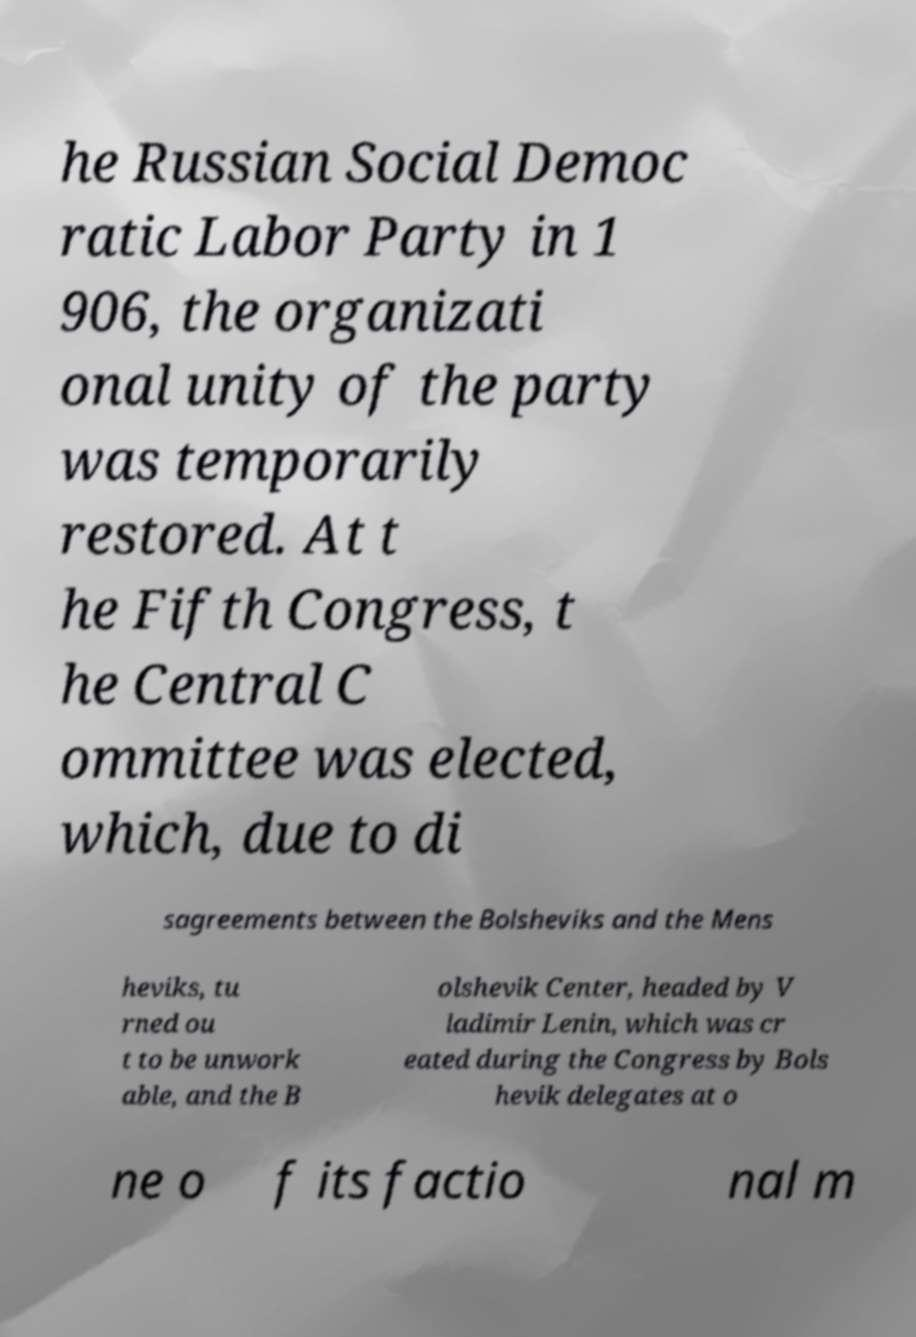Could you assist in decoding the text presented in this image and type it out clearly? he Russian Social Democ ratic Labor Party in 1 906, the organizati onal unity of the party was temporarily restored. At t he Fifth Congress, t he Central C ommittee was elected, which, due to di sagreements between the Bolsheviks and the Mens heviks, tu rned ou t to be unwork able, and the B olshevik Center, headed by V ladimir Lenin, which was cr eated during the Congress by Bols hevik delegates at o ne o f its factio nal m 